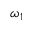<formula> <loc_0><loc_0><loc_500><loc_500>\omega _ { 1 }</formula> 